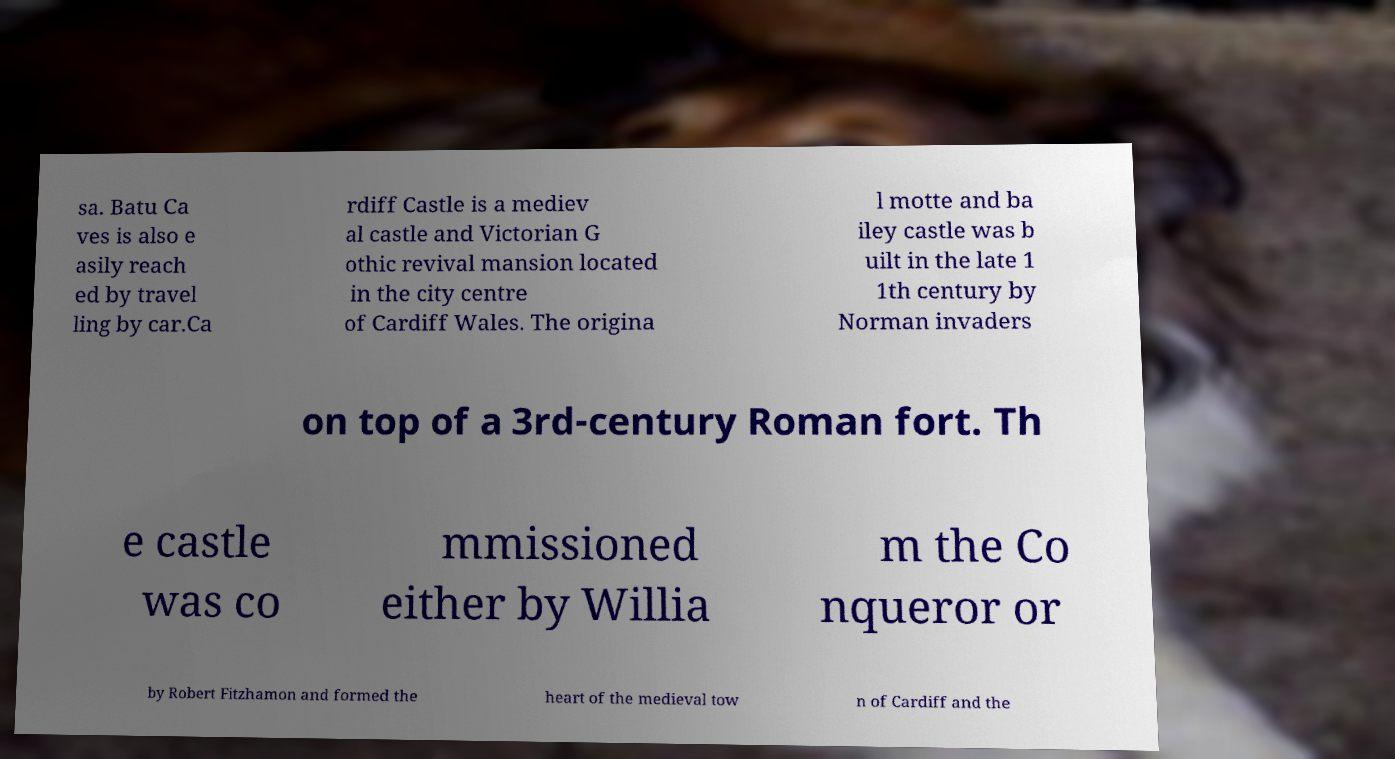Can you accurately transcribe the text from the provided image for me? sa. Batu Ca ves is also e asily reach ed by travel ling by car.Ca rdiff Castle is a mediev al castle and Victorian G othic revival mansion located in the city centre of Cardiff Wales. The origina l motte and ba iley castle was b uilt in the late 1 1th century by Norman invaders on top of a 3rd-century Roman fort. Th e castle was co mmissioned either by Willia m the Co nqueror or by Robert Fitzhamon and formed the heart of the medieval tow n of Cardiff and the 